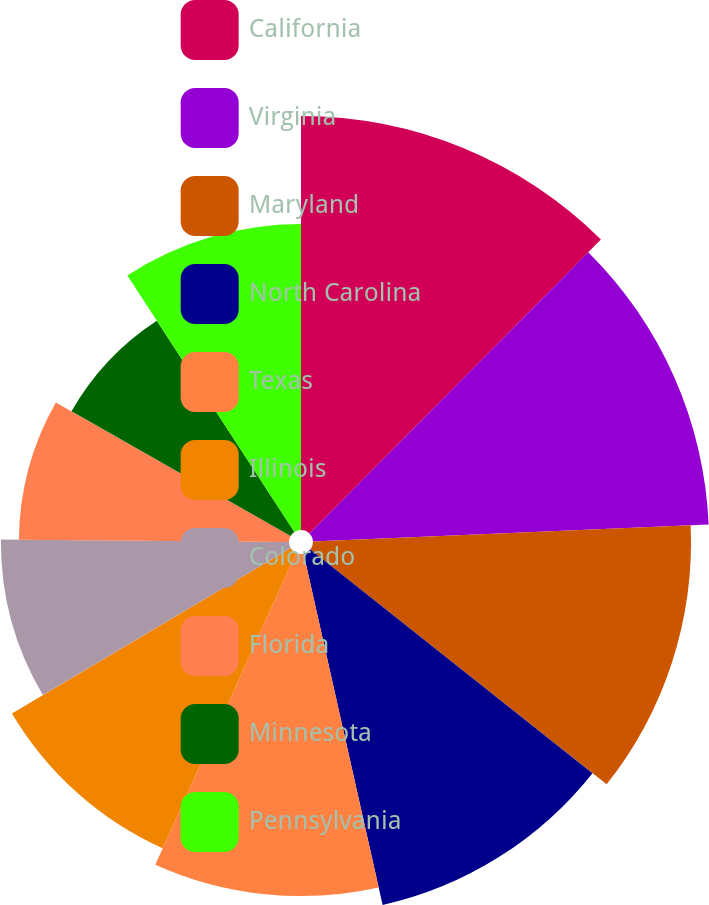<chart> <loc_0><loc_0><loc_500><loc_500><pie_chart><fcel>California<fcel>Virginia<fcel>Maryland<fcel>North Carolina<fcel>Texas<fcel>Illinois<fcel>Colorado<fcel>Florida<fcel>Minnesota<fcel>Pennsylvania<nl><fcel>12.43%<fcel>11.89%<fcel>11.35%<fcel>10.81%<fcel>10.27%<fcel>9.73%<fcel>8.65%<fcel>8.11%<fcel>7.57%<fcel>9.19%<nl></chart> 